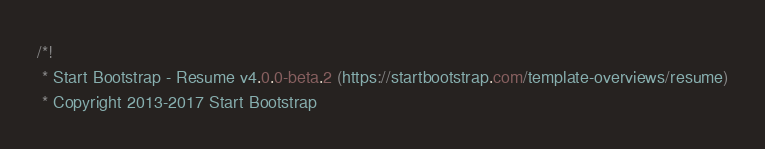<code> <loc_0><loc_0><loc_500><loc_500><_CSS_>/*!
 * Start Bootstrap - Resume v4.0.0-beta.2 (https://startbootstrap.com/template-overviews/resume)
 * Copyright 2013-2017 Start Bootstrap</code> 